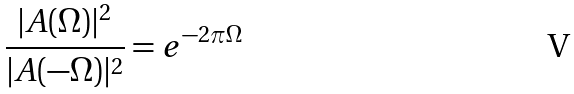Convert formula to latex. <formula><loc_0><loc_0><loc_500><loc_500>\frac { | A ( \Omega ) | ^ { 2 } } { | A ( - \Omega ) | ^ { 2 } } = e ^ { - 2 \pi \Omega }</formula> 